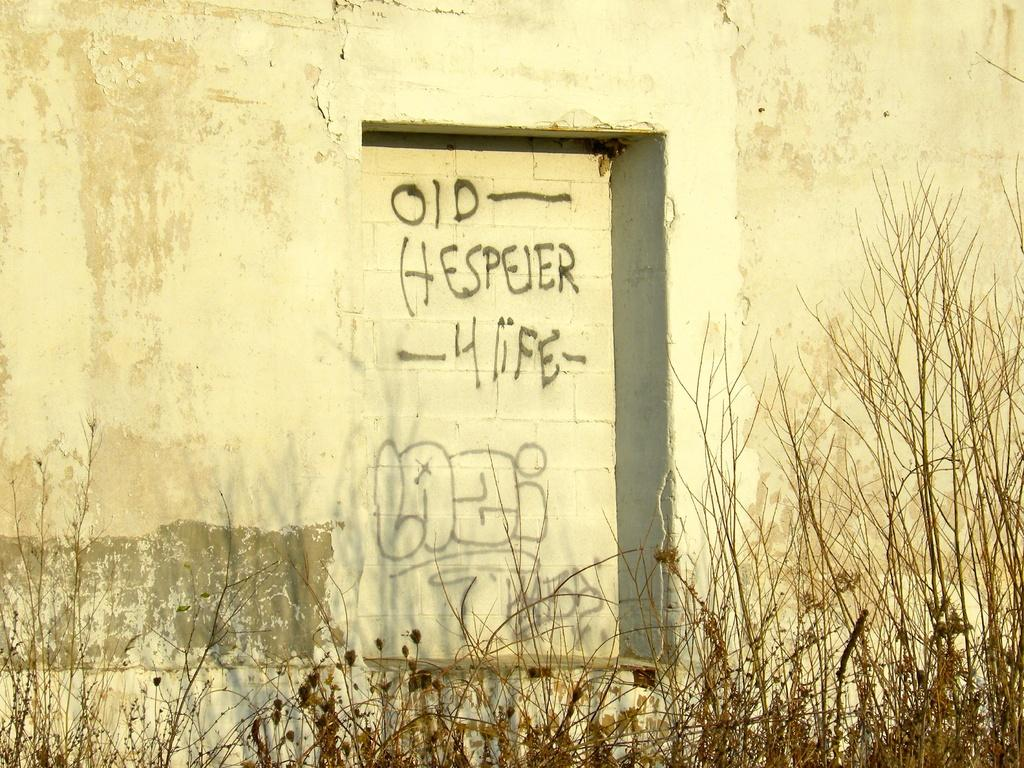What type of living organisms can be seen in the image? Plants can be seen in the image. What is the color of the wall in the image? The wall in the image is white-colored. Is there any text or symbols on the wall? Yes, there is writing on the wall. What type of brick pattern can be seen on the wall in the image? There is no brick pattern visible on the wall in the image; it is a white-colored wall with writing on it. 